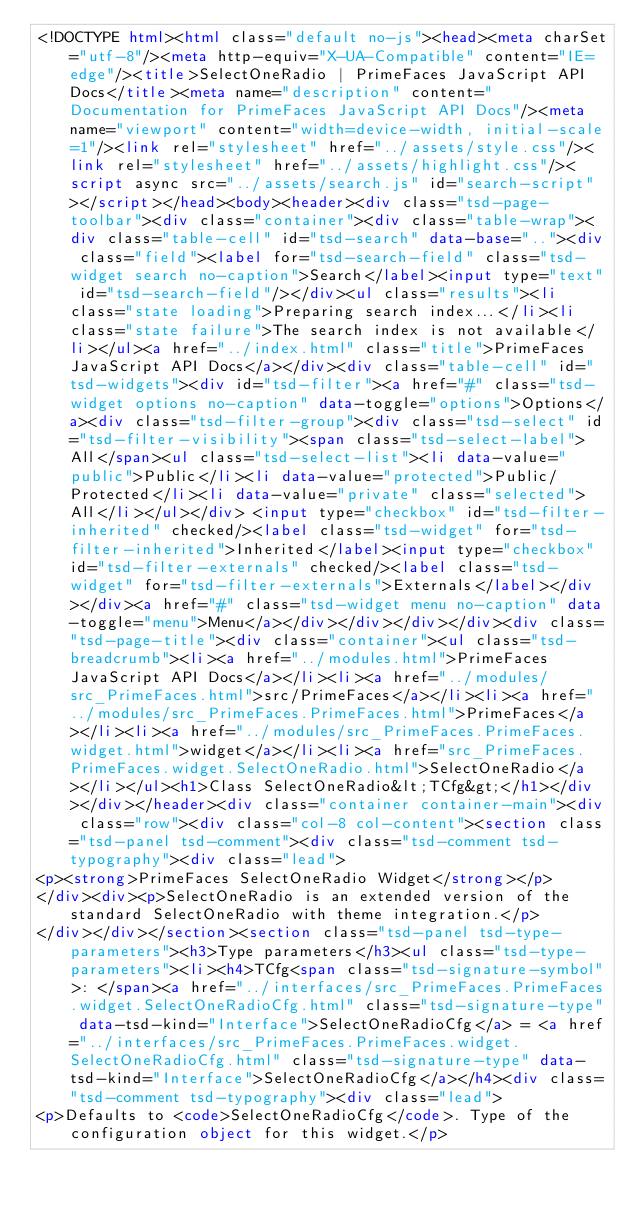Convert code to text. <code><loc_0><loc_0><loc_500><loc_500><_HTML_><!DOCTYPE html><html class="default no-js"><head><meta charSet="utf-8"/><meta http-equiv="X-UA-Compatible" content="IE=edge"/><title>SelectOneRadio | PrimeFaces JavaScript API Docs</title><meta name="description" content="Documentation for PrimeFaces JavaScript API Docs"/><meta name="viewport" content="width=device-width, initial-scale=1"/><link rel="stylesheet" href="../assets/style.css"/><link rel="stylesheet" href="../assets/highlight.css"/><script async src="../assets/search.js" id="search-script"></script></head><body><header><div class="tsd-page-toolbar"><div class="container"><div class="table-wrap"><div class="table-cell" id="tsd-search" data-base=".."><div class="field"><label for="tsd-search-field" class="tsd-widget search no-caption">Search</label><input type="text" id="tsd-search-field"/></div><ul class="results"><li class="state loading">Preparing search index...</li><li class="state failure">The search index is not available</li></ul><a href="../index.html" class="title">PrimeFaces JavaScript API Docs</a></div><div class="table-cell" id="tsd-widgets"><div id="tsd-filter"><a href="#" class="tsd-widget options no-caption" data-toggle="options">Options</a><div class="tsd-filter-group"><div class="tsd-select" id="tsd-filter-visibility"><span class="tsd-select-label">All</span><ul class="tsd-select-list"><li data-value="public">Public</li><li data-value="protected">Public/Protected</li><li data-value="private" class="selected">All</li></ul></div> <input type="checkbox" id="tsd-filter-inherited" checked/><label class="tsd-widget" for="tsd-filter-inherited">Inherited</label><input type="checkbox" id="tsd-filter-externals" checked/><label class="tsd-widget" for="tsd-filter-externals">Externals</label></div></div><a href="#" class="tsd-widget menu no-caption" data-toggle="menu">Menu</a></div></div></div></div><div class="tsd-page-title"><div class="container"><ul class="tsd-breadcrumb"><li><a href="../modules.html">PrimeFaces JavaScript API Docs</a></li><li><a href="../modules/src_PrimeFaces.html">src/PrimeFaces</a></li><li><a href="../modules/src_PrimeFaces.PrimeFaces.html">PrimeFaces</a></li><li><a href="../modules/src_PrimeFaces.PrimeFaces.widget.html">widget</a></li><li><a href="src_PrimeFaces.PrimeFaces.widget.SelectOneRadio.html">SelectOneRadio</a></li></ul><h1>Class SelectOneRadio&lt;TCfg&gt;</h1></div></div></header><div class="container container-main"><div class="row"><div class="col-8 col-content"><section class="tsd-panel tsd-comment"><div class="tsd-comment tsd-typography"><div class="lead">
<p><strong>PrimeFaces SelectOneRadio Widget</strong></p>
</div><div><p>SelectOneRadio is an extended version of the standard SelectOneRadio with theme integration.</p>
</div></div></section><section class="tsd-panel tsd-type-parameters"><h3>Type parameters</h3><ul class="tsd-type-parameters"><li><h4>TCfg<span class="tsd-signature-symbol">: </span><a href="../interfaces/src_PrimeFaces.PrimeFaces.widget.SelectOneRadioCfg.html" class="tsd-signature-type" data-tsd-kind="Interface">SelectOneRadioCfg</a> = <a href="../interfaces/src_PrimeFaces.PrimeFaces.widget.SelectOneRadioCfg.html" class="tsd-signature-type" data-tsd-kind="Interface">SelectOneRadioCfg</a></h4><div class="tsd-comment tsd-typography"><div class="lead">
<p>Defaults to <code>SelectOneRadioCfg</code>. Type of the configuration object for this widget.</p></code> 